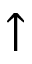<formula> <loc_0><loc_0><loc_500><loc_500>\uparrow</formula> 